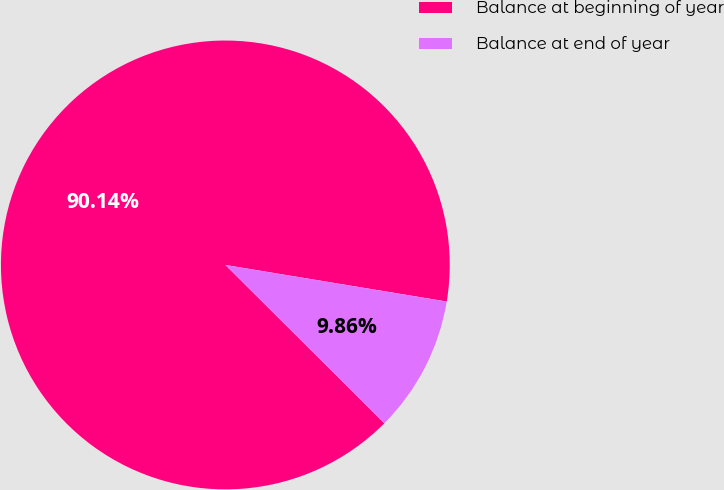Convert chart. <chart><loc_0><loc_0><loc_500><loc_500><pie_chart><fcel>Balance at beginning of year<fcel>Balance at end of year<nl><fcel>90.14%<fcel>9.86%<nl></chart> 